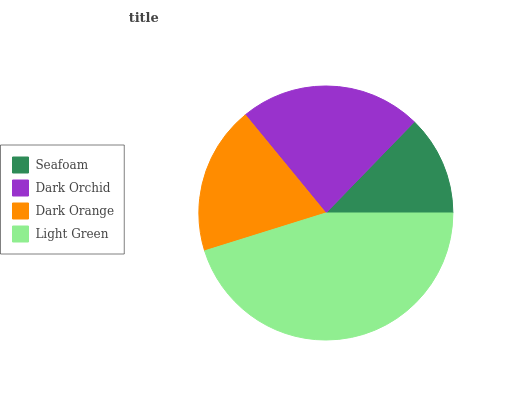Is Seafoam the minimum?
Answer yes or no. Yes. Is Light Green the maximum?
Answer yes or no. Yes. Is Dark Orchid the minimum?
Answer yes or no. No. Is Dark Orchid the maximum?
Answer yes or no. No. Is Dark Orchid greater than Seafoam?
Answer yes or no. Yes. Is Seafoam less than Dark Orchid?
Answer yes or no. Yes. Is Seafoam greater than Dark Orchid?
Answer yes or no. No. Is Dark Orchid less than Seafoam?
Answer yes or no. No. Is Dark Orchid the high median?
Answer yes or no. Yes. Is Dark Orange the low median?
Answer yes or no. Yes. Is Dark Orange the high median?
Answer yes or no. No. Is Dark Orchid the low median?
Answer yes or no. No. 